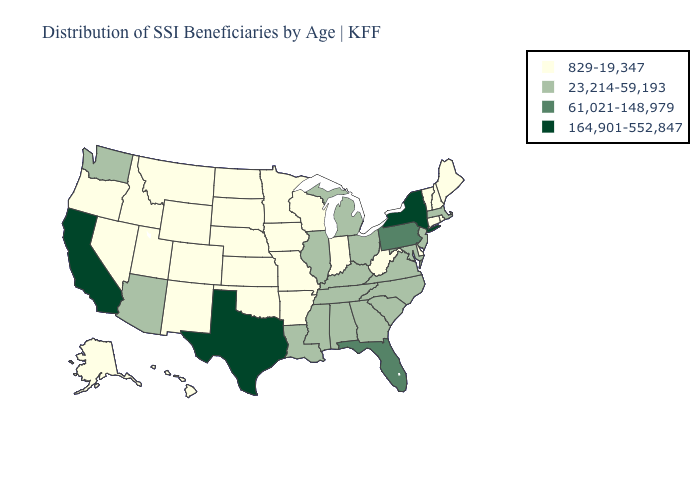What is the lowest value in the USA?
Answer briefly. 829-19,347. Name the states that have a value in the range 23,214-59,193?
Write a very short answer. Alabama, Arizona, Georgia, Illinois, Kentucky, Louisiana, Maryland, Massachusetts, Michigan, Mississippi, New Jersey, North Carolina, Ohio, South Carolina, Tennessee, Virginia, Washington. What is the value of Alabama?
Be succinct. 23,214-59,193. Does Kentucky have a higher value than Maryland?
Keep it brief. No. Among the states that border New Jersey , does New York have the highest value?
Keep it brief. Yes. Which states have the lowest value in the MidWest?
Keep it brief. Indiana, Iowa, Kansas, Minnesota, Missouri, Nebraska, North Dakota, South Dakota, Wisconsin. Name the states that have a value in the range 829-19,347?
Write a very short answer. Alaska, Arkansas, Colorado, Connecticut, Delaware, Hawaii, Idaho, Indiana, Iowa, Kansas, Maine, Minnesota, Missouri, Montana, Nebraska, Nevada, New Hampshire, New Mexico, North Dakota, Oklahoma, Oregon, Rhode Island, South Dakota, Utah, Vermont, West Virginia, Wisconsin, Wyoming. What is the value of Wisconsin?
Be succinct. 829-19,347. Does Nebraska have the lowest value in the MidWest?
Give a very brief answer. Yes. What is the value of Iowa?
Answer briefly. 829-19,347. Among the states that border Alabama , which have the highest value?
Write a very short answer. Florida. What is the lowest value in states that border New York?
Quick response, please. 829-19,347. What is the highest value in states that border Arkansas?
Short answer required. 164,901-552,847. What is the value of Massachusetts?
Quick response, please. 23,214-59,193. What is the highest value in the South ?
Concise answer only. 164,901-552,847. 